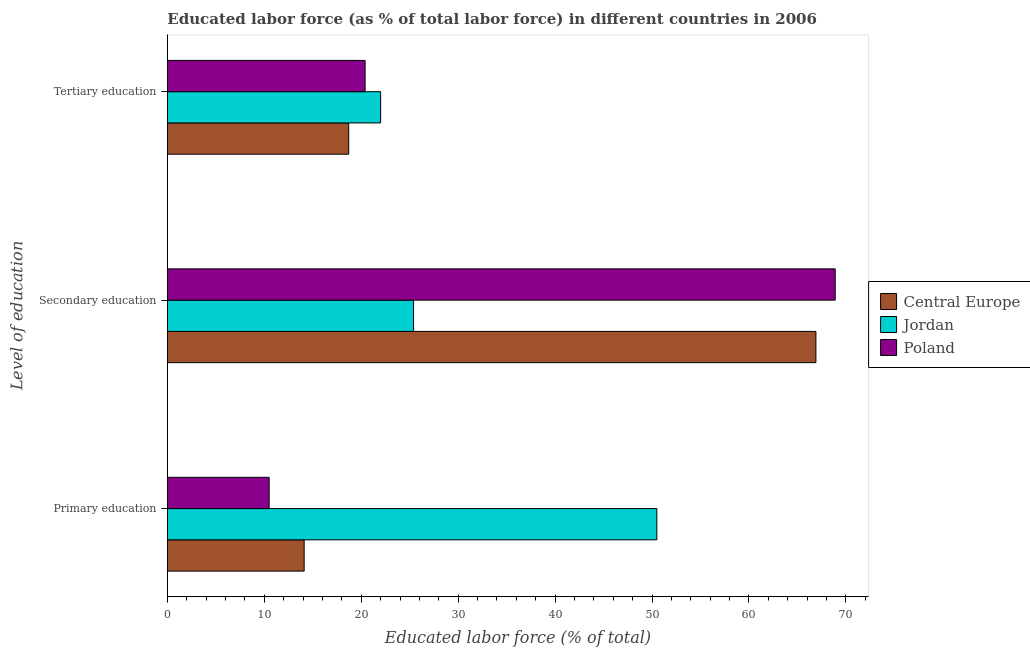How many different coloured bars are there?
Give a very brief answer. 3. Are the number of bars on each tick of the Y-axis equal?
Your answer should be compact. Yes. How many bars are there on the 3rd tick from the bottom?
Provide a short and direct response. 3. What is the label of the 1st group of bars from the top?
Make the answer very short. Tertiary education. What is the percentage of labor force who received secondary education in Central Europe?
Your answer should be very brief. 66.91. Across all countries, what is the maximum percentage of labor force who received primary education?
Provide a succinct answer. 50.5. In which country was the percentage of labor force who received tertiary education maximum?
Your response must be concise. Jordan. In which country was the percentage of labor force who received tertiary education minimum?
Keep it short and to the point. Central Europe. What is the total percentage of labor force who received primary education in the graph?
Provide a short and direct response. 75.11. What is the difference between the percentage of labor force who received tertiary education in Poland and that in Central Europe?
Provide a short and direct response. 1.69. What is the difference between the percentage of labor force who received primary education in Central Europe and the percentage of labor force who received secondary education in Jordan?
Offer a terse response. -11.29. What is the average percentage of labor force who received tertiary education per country?
Provide a short and direct response. 20.37. What is the difference between the percentage of labor force who received tertiary education and percentage of labor force who received secondary education in Poland?
Provide a succinct answer. -48.5. What is the ratio of the percentage of labor force who received primary education in Central Europe to that in Jordan?
Your answer should be very brief. 0.28. Is the percentage of labor force who received secondary education in Poland less than that in Jordan?
Provide a succinct answer. No. Is the difference between the percentage of labor force who received secondary education in Jordan and Poland greater than the difference between the percentage of labor force who received primary education in Jordan and Poland?
Provide a short and direct response. No. What is the difference between the highest and the second highest percentage of labor force who received primary education?
Ensure brevity in your answer.  36.39. What is the difference between the highest and the lowest percentage of labor force who received secondary education?
Provide a succinct answer. 43.5. In how many countries, is the percentage of labor force who received tertiary education greater than the average percentage of labor force who received tertiary education taken over all countries?
Ensure brevity in your answer.  2. Is the sum of the percentage of labor force who received tertiary education in Poland and Central Europe greater than the maximum percentage of labor force who received primary education across all countries?
Give a very brief answer. No. What does the 2nd bar from the top in Secondary education represents?
Offer a terse response. Jordan. What does the 1st bar from the bottom in Secondary education represents?
Ensure brevity in your answer.  Central Europe. Is it the case that in every country, the sum of the percentage of labor force who received primary education and percentage of labor force who received secondary education is greater than the percentage of labor force who received tertiary education?
Your answer should be very brief. Yes. Are all the bars in the graph horizontal?
Keep it short and to the point. Yes. How many countries are there in the graph?
Give a very brief answer. 3. Does the graph contain any zero values?
Make the answer very short. No. Does the graph contain grids?
Make the answer very short. No. How many legend labels are there?
Provide a short and direct response. 3. How are the legend labels stacked?
Provide a succinct answer. Vertical. What is the title of the graph?
Your answer should be very brief. Educated labor force (as % of total labor force) in different countries in 2006. Does "St. Vincent and the Grenadines" appear as one of the legend labels in the graph?
Keep it short and to the point. No. What is the label or title of the X-axis?
Your answer should be very brief. Educated labor force (% of total). What is the label or title of the Y-axis?
Your response must be concise. Level of education. What is the Educated labor force (% of total) of Central Europe in Primary education?
Your answer should be compact. 14.11. What is the Educated labor force (% of total) of Jordan in Primary education?
Make the answer very short. 50.5. What is the Educated labor force (% of total) of Poland in Primary education?
Offer a very short reply. 10.5. What is the Educated labor force (% of total) in Central Europe in Secondary education?
Ensure brevity in your answer.  66.91. What is the Educated labor force (% of total) of Jordan in Secondary education?
Provide a succinct answer. 25.4. What is the Educated labor force (% of total) in Poland in Secondary education?
Keep it short and to the point. 68.9. What is the Educated labor force (% of total) in Central Europe in Tertiary education?
Your answer should be compact. 18.71. What is the Educated labor force (% of total) of Poland in Tertiary education?
Keep it short and to the point. 20.4. Across all Level of education, what is the maximum Educated labor force (% of total) in Central Europe?
Offer a terse response. 66.91. Across all Level of education, what is the maximum Educated labor force (% of total) in Jordan?
Ensure brevity in your answer.  50.5. Across all Level of education, what is the maximum Educated labor force (% of total) of Poland?
Offer a very short reply. 68.9. Across all Level of education, what is the minimum Educated labor force (% of total) of Central Europe?
Your answer should be compact. 14.11. Across all Level of education, what is the minimum Educated labor force (% of total) of Poland?
Keep it short and to the point. 10.5. What is the total Educated labor force (% of total) in Central Europe in the graph?
Give a very brief answer. 99.73. What is the total Educated labor force (% of total) in Jordan in the graph?
Ensure brevity in your answer.  97.9. What is the total Educated labor force (% of total) of Poland in the graph?
Your response must be concise. 99.8. What is the difference between the Educated labor force (% of total) of Central Europe in Primary education and that in Secondary education?
Offer a very short reply. -52.8. What is the difference between the Educated labor force (% of total) in Jordan in Primary education and that in Secondary education?
Provide a short and direct response. 25.1. What is the difference between the Educated labor force (% of total) in Poland in Primary education and that in Secondary education?
Make the answer very short. -58.4. What is the difference between the Educated labor force (% of total) of Central Europe in Primary education and that in Tertiary education?
Offer a very short reply. -4.6. What is the difference between the Educated labor force (% of total) of Jordan in Primary education and that in Tertiary education?
Provide a succinct answer. 28.5. What is the difference between the Educated labor force (% of total) in Central Europe in Secondary education and that in Tertiary education?
Your answer should be compact. 48.2. What is the difference between the Educated labor force (% of total) in Jordan in Secondary education and that in Tertiary education?
Provide a short and direct response. 3.4. What is the difference between the Educated labor force (% of total) in Poland in Secondary education and that in Tertiary education?
Offer a terse response. 48.5. What is the difference between the Educated labor force (% of total) in Central Europe in Primary education and the Educated labor force (% of total) in Jordan in Secondary education?
Your answer should be very brief. -11.29. What is the difference between the Educated labor force (% of total) in Central Europe in Primary education and the Educated labor force (% of total) in Poland in Secondary education?
Your answer should be compact. -54.79. What is the difference between the Educated labor force (% of total) in Jordan in Primary education and the Educated labor force (% of total) in Poland in Secondary education?
Your answer should be very brief. -18.4. What is the difference between the Educated labor force (% of total) of Central Europe in Primary education and the Educated labor force (% of total) of Jordan in Tertiary education?
Make the answer very short. -7.89. What is the difference between the Educated labor force (% of total) of Central Europe in Primary education and the Educated labor force (% of total) of Poland in Tertiary education?
Your answer should be very brief. -6.29. What is the difference between the Educated labor force (% of total) in Jordan in Primary education and the Educated labor force (% of total) in Poland in Tertiary education?
Make the answer very short. 30.1. What is the difference between the Educated labor force (% of total) in Central Europe in Secondary education and the Educated labor force (% of total) in Jordan in Tertiary education?
Provide a short and direct response. 44.91. What is the difference between the Educated labor force (% of total) of Central Europe in Secondary education and the Educated labor force (% of total) of Poland in Tertiary education?
Offer a terse response. 46.51. What is the difference between the Educated labor force (% of total) of Jordan in Secondary education and the Educated labor force (% of total) of Poland in Tertiary education?
Provide a succinct answer. 5. What is the average Educated labor force (% of total) in Central Europe per Level of education?
Give a very brief answer. 33.24. What is the average Educated labor force (% of total) in Jordan per Level of education?
Provide a short and direct response. 32.63. What is the average Educated labor force (% of total) in Poland per Level of education?
Ensure brevity in your answer.  33.27. What is the difference between the Educated labor force (% of total) in Central Europe and Educated labor force (% of total) in Jordan in Primary education?
Your answer should be compact. -36.39. What is the difference between the Educated labor force (% of total) in Central Europe and Educated labor force (% of total) in Poland in Primary education?
Ensure brevity in your answer.  3.61. What is the difference between the Educated labor force (% of total) in Jordan and Educated labor force (% of total) in Poland in Primary education?
Make the answer very short. 40. What is the difference between the Educated labor force (% of total) in Central Europe and Educated labor force (% of total) in Jordan in Secondary education?
Your answer should be very brief. 41.51. What is the difference between the Educated labor force (% of total) in Central Europe and Educated labor force (% of total) in Poland in Secondary education?
Your answer should be very brief. -1.99. What is the difference between the Educated labor force (% of total) in Jordan and Educated labor force (% of total) in Poland in Secondary education?
Provide a short and direct response. -43.5. What is the difference between the Educated labor force (% of total) of Central Europe and Educated labor force (% of total) of Jordan in Tertiary education?
Provide a succinct answer. -3.29. What is the difference between the Educated labor force (% of total) in Central Europe and Educated labor force (% of total) in Poland in Tertiary education?
Your answer should be compact. -1.69. What is the ratio of the Educated labor force (% of total) of Central Europe in Primary education to that in Secondary education?
Provide a succinct answer. 0.21. What is the ratio of the Educated labor force (% of total) of Jordan in Primary education to that in Secondary education?
Your response must be concise. 1.99. What is the ratio of the Educated labor force (% of total) in Poland in Primary education to that in Secondary education?
Your response must be concise. 0.15. What is the ratio of the Educated labor force (% of total) in Central Europe in Primary education to that in Tertiary education?
Provide a short and direct response. 0.75. What is the ratio of the Educated labor force (% of total) of Jordan in Primary education to that in Tertiary education?
Keep it short and to the point. 2.3. What is the ratio of the Educated labor force (% of total) in Poland in Primary education to that in Tertiary education?
Provide a succinct answer. 0.51. What is the ratio of the Educated labor force (% of total) of Central Europe in Secondary education to that in Tertiary education?
Ensure brevity in your answer.  3.58. What is the ratio of the Educated labor force (% of total) of Jordan in Secondary education to that in Tertiary education?
Provide a succinct answer. 1.15. What is the ratio of the Educated labor force (% of total) in Poland in Secondary education to that in Tertiary education?
Your answer should be very brief. 3.38. What is the difference between the highest and the second highest Educated labor force (% of total) of Central Europe?
Offer a terse response. 48.2. What is the difference between the highest and the second highest Educated labor force (% of total) in Jordan?
Provide a short and direct response. 25.1. What is the difference between the highest and the second highest Educated labor force (% of total) in Poland?
Give a very brief answer. 48.5. What is the difference between the highest and the lowest Educated labor force (% of total) in Central Europe?
Keep it short and to the point. 52.8. What is the difference between the highest and the lowest Educated labor force (% of total) of Poland?
Offer a terse response. 58.4. 